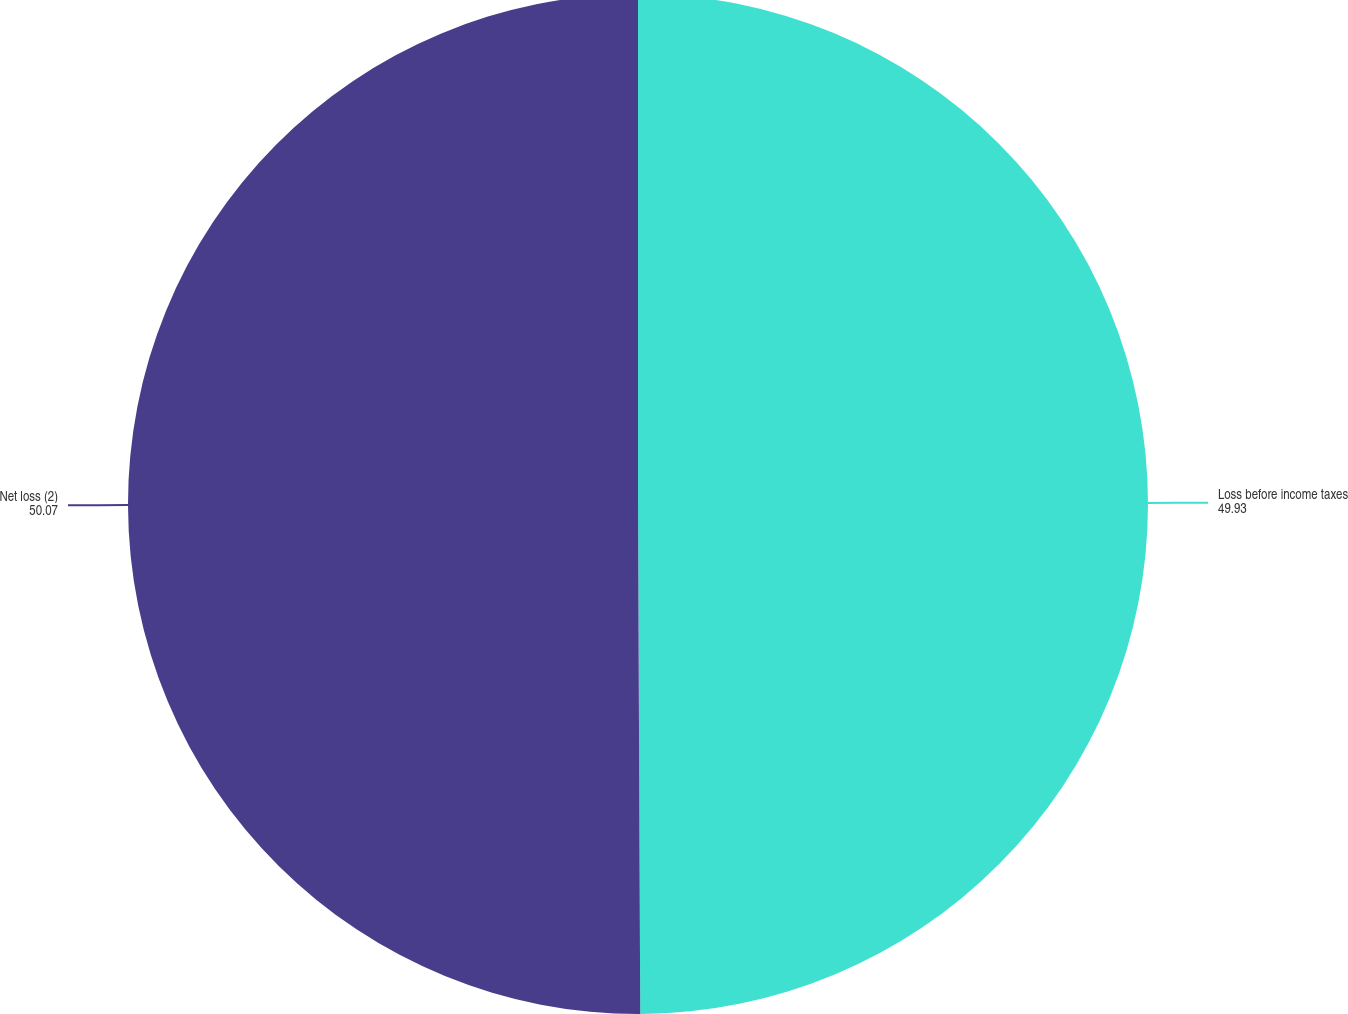Convert chart. <chart><loc_0><loc_0><loc_500><loc_500><pie_chart><fcel>Loss before income taxes<fcel>Net loss (2)<nl><fcel>49.93%<fcel>50.07%<nl></chart> 